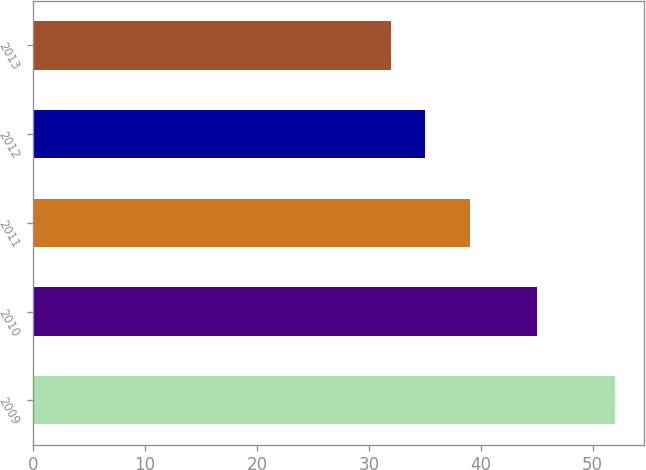<chart> <loc_0><loc_0><loc_500><loc_500><bar_chart><fcel>2009<fcel>2010<fcel>2011<fcel>2012<fcel>2013<nl><fcel>52<fcel>45<fcel>39<fcel>35<fcel>32<nl></chart> 